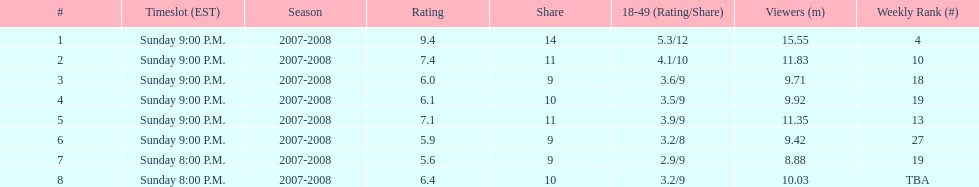How long did the program air for in days? 8. Parse the table in full. {'header': ['#', 'Timeslot (EST)', 'Season', 'Rating', 'Share', '18-49 (Rating/Share)', 'Viewers (m)', 'Weekly Rank (#)'], 'rows': [['1', 'Sunday 9:00 P.M.', '2007-2008', '9.4', '14', '5.3/12', '15.55', '4'], ['2', 'Sunday 9:00 P.M.', '2007-2008', '7.4', '11', '4.1/10', '11.83', '10'], ['3', 'Sunday 9:00 P.M.', '2007-2008', '6.0', '9', '3.6/9', '9.71', '18'], ['4', 'Sunday 9:00 P.M.', '2007-2008', '6.1', '10', '3.5/9', '9.92', '19'], ['5', 'Sunday 9:00 P.M.', '2007-2008', '7.1', '11', '3.9/9', '11.35', '13'], ['6', 'Sunday 9:00 P.M.', '2007-2008', '5.9', '9', '3.2/8', '9.42', '27'], ['7', 'Sunday 8:00 P.M.', '2007-2008', '5.6', '9', '2.9/9', '8.88', '19'], ['8', 'Sunday 8:00 P.M.', '2007-2008', '6.4', '10', '3.2/9', '10.03', 'TBA']]} 